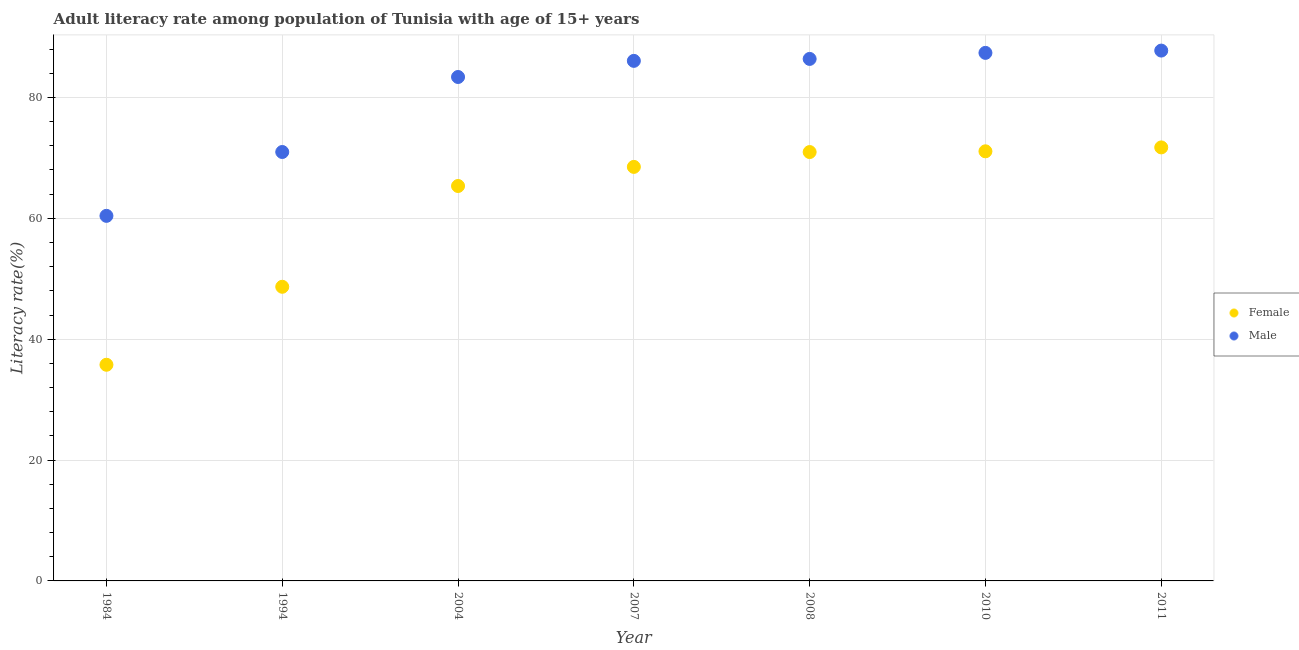How many different coloured dotlines are there?
Offer a very short reply. 2. Is the number of dotlines equal to the number of legend labels?
Provide a short and direct response. Yes. What is the female adult literacy rate in 1984?
Your response must be concise. 35.77. Across all years, what is the maximum male adult literacy rate?
Provide a succinct answer. 87.76. Across all years, what is the minimum female adult literacy rate?
Offer a very short reply. 35.77. In which year was the female adult literacy rate minimum?
Your answer should be very brief. 1984. What is the total male adult literacy rate in the graph?
Offer a very short reply. 562.33. What is the difference between the female adult literacy rate in 2004 and that in 2011?
Ensure brevity in your answer.  -6.39. What is the difference between the female adult literacy rate in 2011 and the male adult literacy rate in 2008?
Provide a short and direct response. -14.64. What is the average female adult literacy rate per year?
Offer a terse response. 61.73. In the year 2004, what is the difference between the female adult literacy rate and male adult literacy rate?
Give a very brief answer. -18.04. In how many years, is the female adult literacy rate greater than 12 %?
Your response must be concise. 7. What is the ratio of the female adult literacy rate in 1984 to that in 2008?
Provide a succinct answer. 0.5. Is the difference between the male adult literacy rate in 2007 and 2011 greater than the difference between the female adult literacy rate in 2007 and 2011?
Provide a succinct answer. Yes. What is the difference between the highest and the second highest male adult literacy rate?
Ensure brevity in your answer.  0.38. What is the difference between the highest and the lowest female adult literacy rate?
Offer a very short reply. 35.97. In how many years, is the female adult literacy rate greater than the average female adult literacy rate taken over all years?
Provide a short and direct response. 5. Is the sum of the male adult literacy rate in 2007 and 2011 greater than the maximum female adult literacy rate across all years?
Your answer should be compact. Yes. Is the male adult literacy rate strictly greater than the female adult literacy rate over the years?
Your response must be concise. Yes. What is the difference between two consecutive major ticks on the Y-axis?
Your answer should be compact. 20. Are the values on the major ticks of Y-axis written in scientific E-notation?
Your answer should be compact. No. Does the graph contain any zero values?
Keep it short and to the point. No. Where does the legend appear in the graph?
Keep it short and to the point. Center right. What is the title of the graph?
Your answer should be compact. Adult literacy rate among population of Tunisia with age of 15+ years. What is the label or title of the Y-axis?
Offer a terse response. Literacy rate(%). What is the Literacy rate(%) of Female in 1984?
Provide a short and direct response. 35.77. What is the Literacy rate(%) of Male in 1984?
Ensure brevity in your answer.  60.41. What is the Literacy rate(%) of Female in 1994?
Provide a succinct answer. 48.67. What is the Literacy rate(%) of Male in 1994?
Ensure brevity in your answer.  70.97. What is the Literacy rate(%) in Female in 2004?
Your answer should be compact. 65.35. What is the Literacy rate(%) of Male in 2004?
Make the answer very short. 83.39. What is the Literacy rate(%) of Female in 2007?
Your response must be concise. 68.51. What is the Literacy rate(%) of Male in 2007?
Your answer should be very brief. 86.05. What is the Literacy rate(%) of Female in 2008?
Offer a terse response. 70.96. What is the Literacy rate(%) in Male in 2008?
Give a very brief answer. 86.38. What is the Literacy rate(%) of Female in 2010?
Give a very brief answer. 71.09. What is the Literacy rate(%) in Male in 2010?
Keep it short and to the point. 87.38. What is the Literacy rate(%) of Female in 2011?
Give a very brief answer. 71.73. What is the Literacy rate(%) of Male in 2011?
Your response must be concise. 87.76. Across all years, what is the maximum Literacy rate(%) in Female?
Give a very brief answer. 71.73. Across all years, what is the maximum Literacy rate(%) of Male?
Provide a short and direct response. 87.76. Across all years, what is the minimum Literacy rate(%) in Female?
Your answer should be very brief. 35.77. Across all years, what is the minimum Literacy rate(%) of Male?
Provide a short and direct response. 60.41. What is the total Literacy rate(%) in Female in the graph?
Ensure brevity in your answer.  432.08. What is the total Literacy rate(%) of Male in the graph?
Keep it short and to the point. 562.33. What is the difference between the Literacy rate(%) of Female in 1984 and that in 1994?
Give a very brief answer. -12.9. What is the difference between the Literacy rate(%) in Male in 1984 and that in 1994?
Keep it short and to the point. -10.57. What is the difference between the Literacy rate(%) of Female in 1984 and that in 2004?
Make the answer very short. -29.58. What is the difference between the Literacy rate(%) in Male in 1984 and that in 2004?
Keep it short and to the point. -22.98. What is the difference between the Literacy rate(%) in Female in 1984 and that in 2007?
Provide a succinct answer. -32.74. What is the difference between the Literacy rate(%) of Male in 1984 and that in 2007?
Give a very brief answer. -25.65. What is the difference between the Literacy rate(%) in Female in 1984 and that in 2008?
Give a very brief answer. -35.2. What is the difference between the Literacy rate(%) of Male in 1984 and that in 2008?
Ensure brevity in your answer.  -25.97. What is the difference between the Literacy rate(%) in Female in 1984 and that in 2010?
Provide a succinct answer. -35.32. What is the difference between the Literacy rate(%) in Male in 1984 and that in 2010?
Ensure brevity in your answer.  -26.97. What is the difference between the Literacy rate(%) in Female in 1984 and that in 2011?
Provide a succinct answer. -35.97. What is the difference between the Literacy rate(%) in Male in 1984 and that in 2011?
Give a very brief answer. -27.35. What is the difference between the Literacy rate(%) in Female in 1994 and that in 2004?
Give a very brief answer. -16.68. What is the difference between the Literacy rate(%) of Male in 1994 and that in 2004?
Your response must be concise. -12.41. What is the difference between the Literacy rate(%) of Female in 1994 and that in 2007?
Keep it short and to the point. -19.84. What is the difference between the Literacy rate(%) of Male in 1994 and that in 2007?
Give a very brief answer. -15.08. What is the difference between the Literacy rate(%) of Female in 1994 and that in 2008?
Your answer should be compact. -22.29. What is the difference between the Literacy rate(%) in Male in 1994 and that in 2008?
Make the answer very short. -15.4. What is the difference between the Literacy rate(%) of Female in 1994 and that in 2010?
Keep it short and to the point. -22.42. What is the difference between the Literacy rate(%) in Male in 1994 and that in 2010?
Ensure brevity in your answer.  -16.4. What is the difference between the Literacy rate(%) of Female in 1994 and that in 2011?
Offer a terse response. -23.06. What is the difference between the Literacy rate(%) in Male in 1994 and that in 2011?
Keep it short and to the point. -16.78. What is the difference between the Literacy rate(%) of Female in 2004 and that in 2007?
Make the answer very short. -3.16. What is the difference between the Literacy rate(%) of Male in 2004 and that in 2007?
Make the answer very short. -2.67. What is the difference between the Literacy rate(%) of Female in 2004 and that in 2008?
Ensure brevity in your answer.  -5.62. What is the difference between the Literacy rate(%) of Male in 2004 and that in 2008?
Keep it short and to the point. -2.99. What is the difference between the Literacy rate(%) of Female in 2004 and that in 2010?
Your answer should be compact. -5.74. What is the difference between the Literacy rate(%) in Male in 2004 and that in 2010?
Your response must be concise. -3.99. What is the difference between the Literacy rate(%) of Female in 2004 and that in 2011?
Make the answer very short. -6.39. What is the difference between the Literacy rate(%) of Male in 2004 and that in 2011?
Keep it short and to the point. -4.37. What is the difference between the Literacy rate(%) in Female in 2007 and that in 2008?
Provide a short and direct response. -2.45. What is the difference between the Literacy rate(%) in Male in 2007 and that in 2008?
Offer a terse response. -0.32. What is the difference between the Literacy rate(%) in Female in 2007 and that in 2010?
Offer a terse response. -2.58. What is the difference between the Literacy rate(%) of Male in 2007 and that in 2010?
Your answer should be compact. -1.32. What is the difference between the Literacy rate(%) in Female in 2007 and that in 2011?
Give a very brief answer. -3.22. What is the difference between the Literacy rate(%) of Male in 2007 and that in 2011?
Provide a succinct answer. -1.7. What is the difference between the Literacy rate(%) in Female in 2008 and that in 2010?
Keep it short and to the point. -0.12. What is the difference between the Literacy rate(%) of Male in 2008 and that in 2010?
Your answer should be compact. -1. What is the difference between the Literacy rate(%) of Female in 2008 and that in 2011?
Ensure brevity in your answer.  -0.77. What is the difference between the Literacy rate(%) in Male in 2008 and that in 2011?
Your answer should be compact. -1.38. What is the difference between the Literacy rate(%) of Female in 2010 and that in 2011?
Give a very brief answer. -0.65. What is the difference between the Literacy rate(%) in Male in 2010 and that in 2011?
Keep it short and to the point. -0.38. What is the difference between the Literacy rate(%) of Female in 1984 and the Literacy rate(%) of Male in 1994?
Keep it short and to the point. -35.21. What is the difference between the Literacy rate(%) of Female in 1984 and the Literacy rate(%) of Male in 2004?
Provide a succinct answer. -47.62. What is the difference between the Literacy rate(%) of Female in 1984 and the Literacy rate(%) of Male in 2007?
Give a very brief answer. -50.29. What is the difference between the Literacy rate(%) of Female in 1984 and the Literacy rate(%) of Male in 2008?
Ensure brevity in your answer.  -50.61. What is the difference between the Literacy rate(%) of Female in 1984 and the Literacy rate(%) of Male in 2010?
Ensure brevity in your answer.  -51.61. What is the difference between the Literacy rate(%) of Female in 1984 and the Literacy rate(%) of Male in 2011?
Your answer should be very brief. -51.99. What is the difference between the Literacy rate(%) in Female in 1994 and the Literacy rate(%) in Male in 2004?
Provide a succinct answer. -34.71. What is the difference between the Literacy rate(%) in Female in 1994 and the Literacy rate(%) in Male in 2007?
Ensure brevity in your answer.  -37.38. What is the difference between the Literacy rate(%) in Female in 1994 and the Literacy rate(%) in Male in 2008?
Your answer should be very brief. -37.7. What is the difference between the Literacy rate(%) of Female in 1994 and the Literacy rate(%) of Male in 2010?
Your answer should be very brief. -38.7. What is the difference between the Literacy rate(%) in Female in 1994 and the Literacy rate(%) in Male in 2011?
Your response must be concise. -39.08. What is the difference between the Literacy rate(%) in Female in 2004 and the Literacy rate(%) in Male in 2007?
Offer a very short reply. -20.71. What is the difference between the Literacy rate(%) of Female in 2004 and the Literacy rate(%) of Male in 2008?
Ensure brevity in your answer.  -21.03. What is the difference between the Literacy rate(%) in Female in 2004 and the Literacy rate(%) in Male in 2010?
Offer a very short reply. -22.03. What is the difference between the Literacy rate(%) in Female in 2004 and the Literacy rate(%) in Male in 2011?
Your response must be concise. -22.41. What is the difference between the Literacy rate(%) in Female in 2007 and the Literacy rate(%) in Male in 2008?
Keep it short and to the point. -17.87. What is the difference between the Literacy rate(%) in Female in 2007 and the Literacy rate(%) in Male in 2010?
Give a very brief answer. -18.87. What is the difference between the Literacy rate(%) in Female in 2007 and the Literacy rate(%) in Male in 2011?
Your response must be concise. -19.25. What is the difference between the Literacy rate(%) of Female in 2008 and the Literacy rate(%) of Male in 2010?
Your response must be concise. -16.41. What is the difference between the Literacy rate(%) in Female in 2008 and the Literacy rate(%) in Male in 2011?
Provide a short and direct response. -16.79. What is the difference between the Literacy rate(%) in Female in 2010 and the Literacy rate(%) in Male in 2011?
Give a very brief answer. -16.67. What is the average Literacy rate(%) in Female per year?
Offer a terse response. 61.73. What is the average Literacy rate(%) in Male per year?
Offer a terse response. 80.33. In the year 1984, what is the difference between the Literacy rate(%) of Female and Literacy rate(%) of Male?
Your answer should be very brief. -24.64. In the year 1994, what is the difference between the Literacy rate(%) in Female and Literacy rate(%) in Male?
Offer a terse response. -22.3. In the year 2004, what is the difference between the Literacy rate(%) of Female and Literacy rate(%) of Male?
Give a very brief answer. -18.04. In the year 2007, what is the difference between the Literacy rate(%) of Female and Literacy rate(%) of Male?
Provide a short and direct response. -17.54. In the year 2008, what is the difference between the Literacy rate(%) of Female and Literacy rate(%) of Male?
Make the answer very short. -15.41. In the year 2010, what is the difference between the Literacy rate(%) of Female and Literacy rate(%) of Male?
Provide a succinct answer. -16.29. In the year 2011, what is the difference between the Literacy rate(%) in Female and Literacy rate(%) in Male?
Provide a short and direct response. -16.02. What is the ratio of the Literacy rate(%) in Female in 1984 to that in 1994?
Provide a short and direct response. 0.73. What is the ratio of the Literacy rate(%) of Male in 1984 to that in 1994?
Offer a terse response. 0.85. What is the ratio of the Literacy rate(%) in Female in 1984 to that in 2004?
Offer a very short reply. 0.55. What is the ratio of the Literacy rate(%) of Male in 1984 to that in 2004?
Provide a succinct answer. 0.72. What is the ratio of the Literacy rate(%) of Female in 1984 to that in 2007?
Offer a very short reply. 0.52. What is the ratio of the Literacy rate(%) of Male in 1984 to that in 2007?
Provide a succinct answer. 0.7. What is the ratio of the Literacy rate(%) in Female in 1984 to that in 2008?
Provide a short and direct response. 0.5. What is the ratio of the Literacy rate(%) of Male in 1984 to that in 2008?
Give a very brief answer. 0.7. What is the ratio of the Literacy rate(%) in Female in 1984 to that in 2010?
Your answer should be compact. 0.5. What is the ratio of the Literacy rate(%) of Male in 1984 to that in 2010?
Provide a succinct answer. 0.69. What is the ratio of the Literacy rate(%) in Female in 1984 to that in 2011?
Your answer should be compact. 0.5. What is the ratio of the Literacy rate(%) in Male in 1984 to that in 2011?
Your answer should be compact. 0.69. What is the ratio of the Literacy rate(%) of Female in 1994 to that in 2004?
Provide a short and direct response. 0.74. What is the ratio of the Literacy rate(%) of Male in 1994 to that in 2004?
Provide a short and direct response. 0.85. What is the ratio of the Literacy rate(%) of Female in 1994 to that in 2007?
Your response must be concise. 0.71. What is the ratio of the Literacy rate(%) of Male in 1994 to that in 2007?
Your answer should be compact. 0.82. What is the ratio of the Literacy rate(%) of Female in 1994 to that in 2008?
Your answer should be very brief. 0.69. What is the ratio of the Literacy rate(%) in Male in 1994 to that in 2008?
Keep it short and to the point. 0.82. What is the ratio of the Literacy rate(%) of Female in 1994 to that in 2010?
Your answer should be very brief. 0.68. What is the ratio of the Literacy rate(%) in Male in 1994 to that in 2010?
Your answer should be compact. 0.81. What is the ratio of the Literacy rate(%) of Female in 1994 to that in 2011?
Your answer should be compact. 0.68. What is the ratio of the Literacy rate(%) in Male in 1994 to that in 2011?
Keep it short and to the point. 0.81. What is the ratio of the Literacy rate(%) in Female in 2004 to that in 2007?
Your answer should be very brief. 0.95. What is the ratio of the Literacy rate(%) in Male in 2004 to that in 2007?
Offer a terse response. 0.97. What is the ratio of the Literacy rate(%) in Female in 2004 to that in 2008?
Provide a succinct answer. 0.92. What is the ratio of the Literacy rate(%) of Male in 2004 to that in 2008?
Offer a very short reply. 0.97. What is the ratio of the Literacy rate(%) of Female in 2004 to that in 2010?
Provide a short and direct response. 0.92. What is the ratio of the Literacy rate(%) in Male in 2004 to that in 2010?
Your response must be concise. 0.95. What is the ratio of the Literacy rate(%) in Female in 2004 to that in 2011?
Your answer should be compact. 0.91. What is the ratio of the Literacy rate(%) of Male in 2004 to that in 2011?
Your answer should be compact. 0.95. What is the ratio of the Literacy rate(%) in Female in 2007 to that in 2008?
Your answer should be very brief. 0.97. What is the ratio of the Literacy rate(%) in Female in 2007 to that in 2010?
Your answer should be compact. 0.96. What is the ratio of the Literacy rate(%) of Male in 2007 to that in 2010?
Give a very brief answer. 0.98. What is the ratio of the Literacy rate(%) in Female in 2007 to that in 2011?
Your answer should be very brief. 0.95. What is the ratio of the Literacy rate(%) of Male in 2007 to that in 2011?
Make the answer very short. 0.98. What is the ratio of the Literacy rate(%) of Female in 2008 to that in 2010?
Ensure brevity in your answer.  1. What is the ratio of the Literacy rate(%) of Male in 2008 to that in 2010?
Make the answer very short. 0.99. What is the ratio of the Literacy rate(%) in Female in 2008 to that in 2011?
Offer a terse response. 0.99. What is the ratio of the Literacy rate(%) of Male in 2008 to that in 2011?
Keep it short and to the point. 0.98. What is the ratio of the Literacy rate(%) of Female in 2010 to that in 2011?
Your answer should be compact. 0.99. What is the difference between the highest and the second highest Literacy rate(%) of Female?
Your answer should be very brief. 0.65. What is the difference between the highest and the second highest Literacy rate(%) of Male?
Provide a short and direct response. 0.38. What is the difference between the highest and the lowest Literacy rate(%) in Female?
Ensure brevity in your answer.  35.97. What is the difference between the highest and the lowest Literacy rate(%) in Male?
Keep it short and to the point. 27.35. 